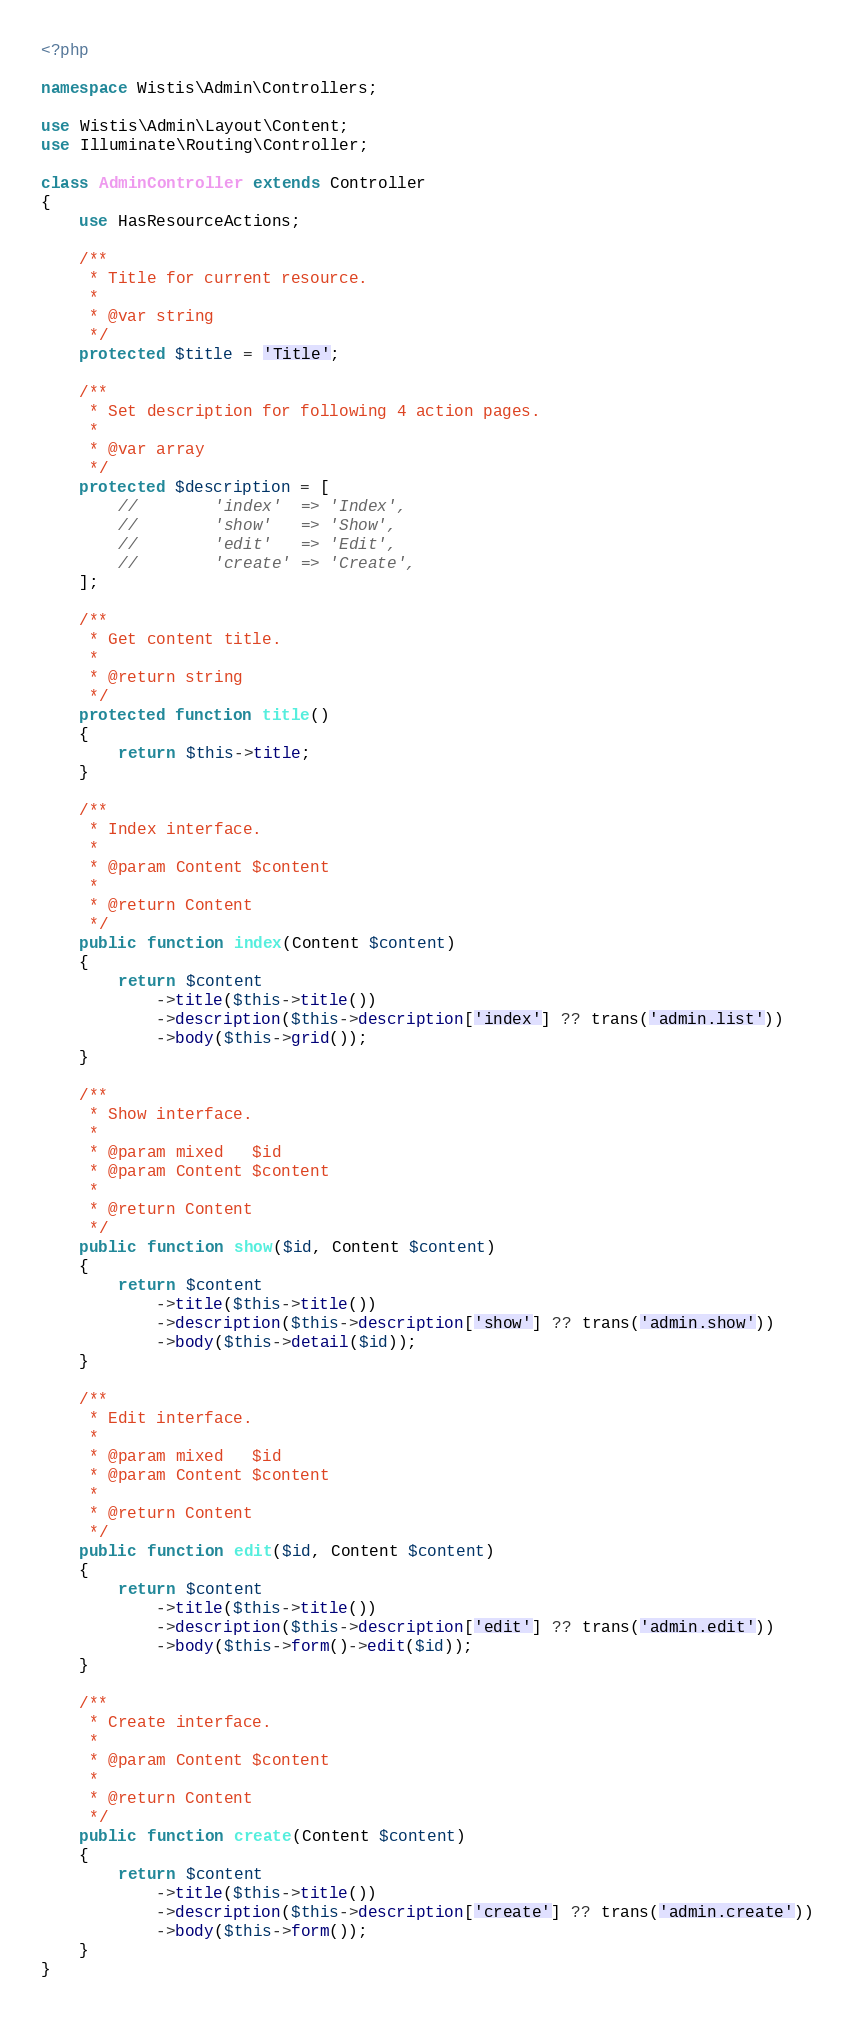<code> <loc_0><loc_0><loc_500><loc_500><_PHP_><?php

namespace Wistis\Admin\Controllers;

use Wistis\Admin\Layout\Content;
use Illuminate\Routing\Controller;

class AdminController extends Controller
{
    use HasResourceActions;

    /**
     * Title for current resource.
     *
     * @var string
     */
    protected $title = 'Title';

    /**
     * Set description for following 4 action pages.
     *
     * @var array
     */
    protected $description = [
        //        'index'  => 'Index',
        //        'show'   => 'Show',
        //        'edit'   => 'Edit',
        //        'create' => 'Create',
    ];

    /**
     * Get content title.
     *
     * @return string
     */
    protected function title()
    {
        return $this->title;
    }

    /**
     * Index interface.
     *
     * @param Content $content
     *
     * @return Content
     */
    public function index(Content $content)
    {
        return $content
            ->title($this->title())
            ->description($this->description['index'] ?? trans('admin.list'))
            ->body($this->grid());
    }

    /**
     * Show interface.
     *
     * @param mixed   $id
     * @param Content $content
     *
     * @return Content
     */
    public function show($id, Content $content)
    {
        return $content
            ->title($this->title())
            ->description($this->description['show'] ?? trans('admin.show'))
            ->body($this->detail($id));
    }

    /**
     * Edit interface.
     *
     * @param mixed   $id
     * @param Content $content
     *
     * @return Content
     */
    public function edit($id, Content $content)
    {
        return $content
            ->title($this->title())
            ->description($this->description['edit'] ?? trans('admin.edit'))
            ->body($this->form()->edit($id));
    }

    /**
     * Create interface.
     *
     * @param Content $content
     *
     * @return Content
     */
    public function create(Content $content)
    {
        return $content
            ->title($this->title())
            ->description($this->description['create'] ?? trans('admin.create'))
            ->body($this->form());
    }
}
</code> 